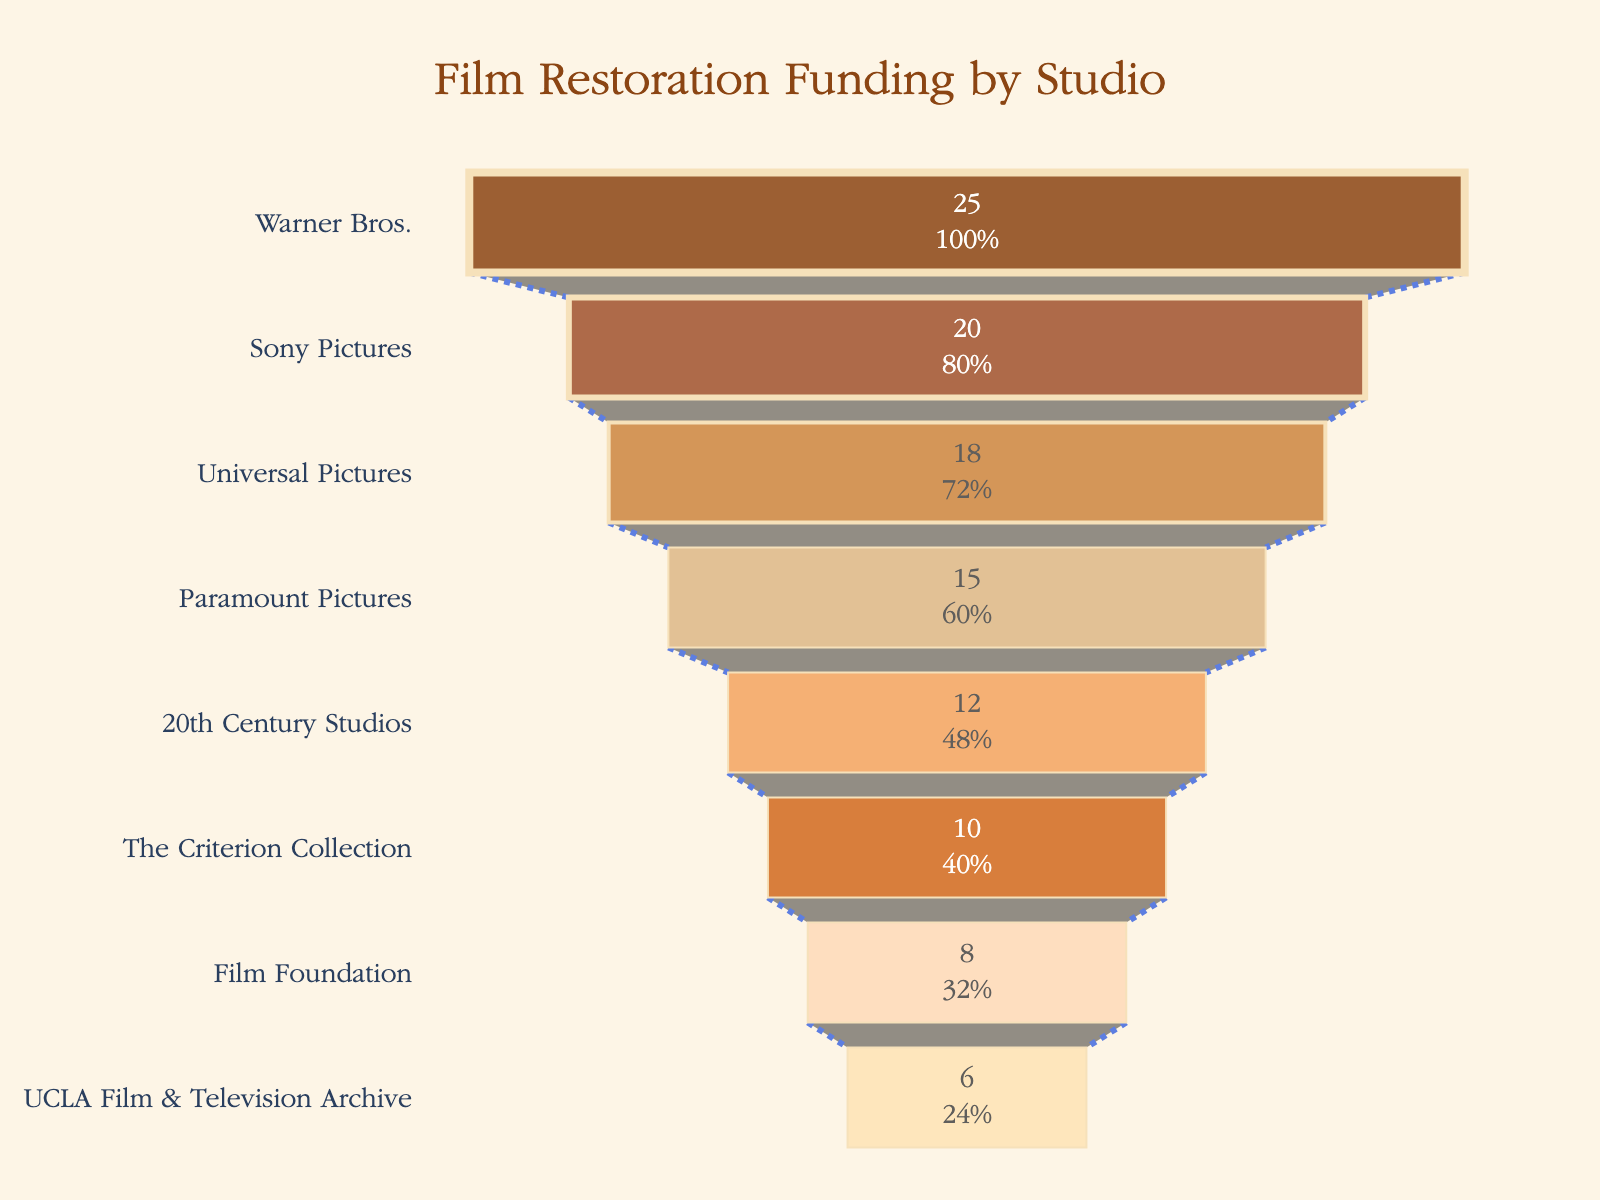Which studio received the highest funding allocation for film restoration projects? The studio at the top of the funnel with the largest segment represents the highest funding allocation, which is Warner Bros.
Answer: Warner Bros What is the total funding allocated to Sony Pictures and Universal Pictures combined? Add the funding allocations of Sony Pictures (20M) and Universal Pictures (18M): 20 + 18 = 38M.
Answer: 38M Which studio received less funding for restoration projects: 20th Century Studios or The Criterion Collection? Comparing the lengths of the segments for 20th Century Studios (12M) and The Criterion Collection (10M), The Criterion Collection received less funding.
Answer: The Criterion Collection How much more funding did Paramount Pictures receive compared to the UCLA Film & Television Archive? Subtract UCLA Film & Television Archive's funding (6M) from Paramount Pictures' funding (15M): 15 - 6 = 9M.
Answer: 9M If the total funding for all studios is summarized, what is the average allocation per studio? First, sum up all the funding allocations: 25 + 20 + 18 + 15 + 12 + 10 + 8 + 6 = 114M. Then, divide by the number of studios (8): 114 / 8 = 14.25M.
Answer: 14.25M Which studio has the smallest funding allocation, and what percentage of the total funding does it represent? The smallest segment in the funnel chart belongs to the UCLA Film & Television Archive with 6M. To find the percentage: (6 / 114) * 100 = 5.26%.
Answer: UCLA Film & Television Archive, 5.26% What is the funding difference between the studio with the highest allocation and the studio with the lowest allocation? The highest allocation is for Warner Bros. (25M) and the lowest for UCLA Film & Television Archive (6M). Subtract UCLA's funding from Warner Bros': 25 - 6 = 19M.
Answer: 19M Compare the combined funding of Film Foundation and The Criterion Collection with the funding allocated to Warner Bros. Sum the allocations for Film Foundation (8M) and The Criterion Collection (10M): 8 + 10 = 18M. Warner Bros. has 25M, which is more than the combined funding (18M).
Answer: Warner Bros. has more What percentage of the total funding is allocated to Paramount Pictures? Percentage is calculated by: (15 / 114) * 100 = 13.16%.
Answer: 13.16% 